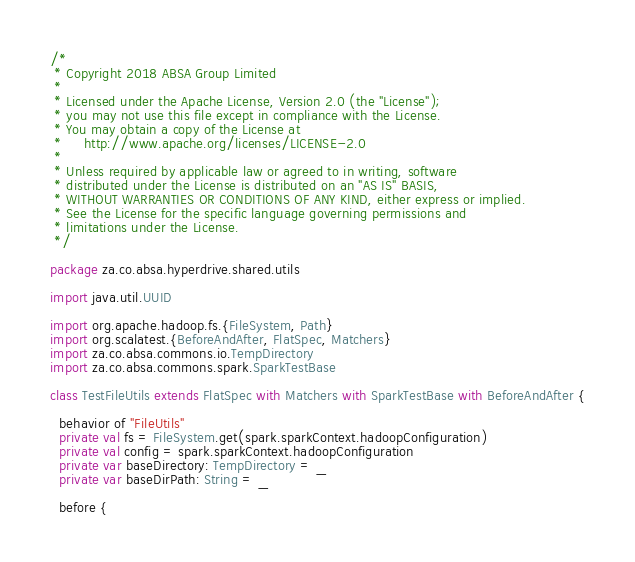Convert code to text. <code><loc_0><loc_0><loc_500><loc_500><_Scala_>/*
 * Copyright 2018 ABSA Group Limited
 *
 * Licensed under the Apache License, Version 2.0 (the "License");
 * you may not use this file except in compliance with the License.
 * You may obtain a copy of the License at
 *     http://www.apache.org/licenses/LICENSE-2.0
 *
 * Unless required by applicable law or agreed to in writing, software
 * distributed under the License is distributed on an "AS IS" BASIS,
 * WITHOUT WARRANTIES OR CONDITIONS OF ANY KIND, either express or implied.
 * See the License for the specific language governing permissions and
 * limitations under the License.
 */

package za.co.absa.hyperdrive.shared.utils

import java.util.UUID

import org.apache.hadoop.fs.{FileSystem, Path}
import org.scalatest.{BeforeAndAfter, FlatSpec, Matchers}
import za.co.absa.commons.io.TempDirectory
import za.co.absa.commons.spark.SparkTestBase

class TestFileUtils extends FlatSpec with Matchers with SparkTestBase with BeforeAndAfter {

  behavior of "FileUtils"
  private val fs = FileSystem.get(spark.sparkContext.hadoopConfiguration)
  private val config = spark.sparkContext.hadoopConfiguration
  private var baseDirectory: TempDirectory = _
  private var baseDirPath: String = _

  before {</code> 